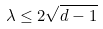Convert formula to latex. <formula><loc_0><loc_0><loc_500><loc_500>\lambda \leq 2 \sqrt { d - 1 }</formula> 